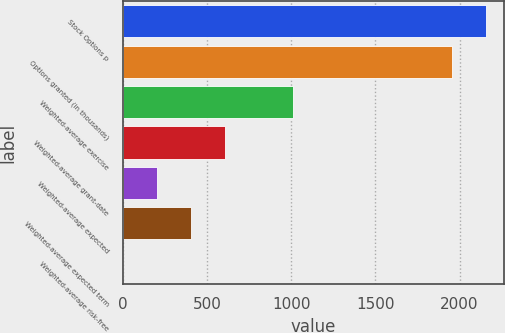Convert chart. <chart><loc_0><loc_0><loc_500><loc_500><bar_chart><fcel>Stock Options p<fcel>Options granted (in thousands)<fcel>Weighted-average exercise<fcel>Weighted-average grant-date<fcel>Weighted-average expected<fcel>Weighted-average expected term<fcel>Weighted-average risk-free<nl><fcel>2155.34<fcel>1954<fcel>1008.3<fcel>605.62<fcel>202.94<fcel>404.28<fcel>1.6<nl></chart> 